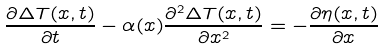<formula> <loc_0><loc_0><loc_500><loc_500>\frac { \partial \Delta T ( x , t ) } { \partial t } - \alpha ( x ) \frac { \partial ^ { 2 } \Delta T ( x , t ) } { \partial x ^ { 2 } } = - \frac { \partial \eta ( x , t ) } { \partial x }</formula> 